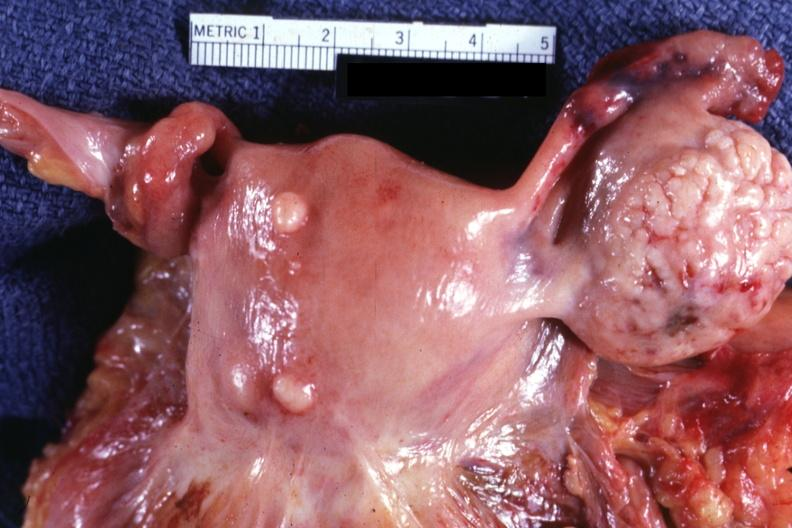what are small normal ovary is in photo?
Answer the question using a single word or phrase. Intramural one lesion 